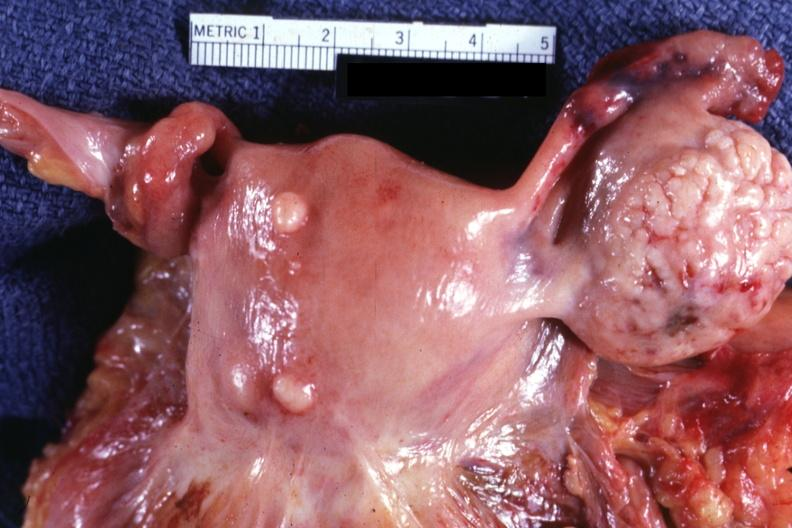what are small normal ovary is in photo?
Answer the question using a single word or phrase. Intramural one lesion 